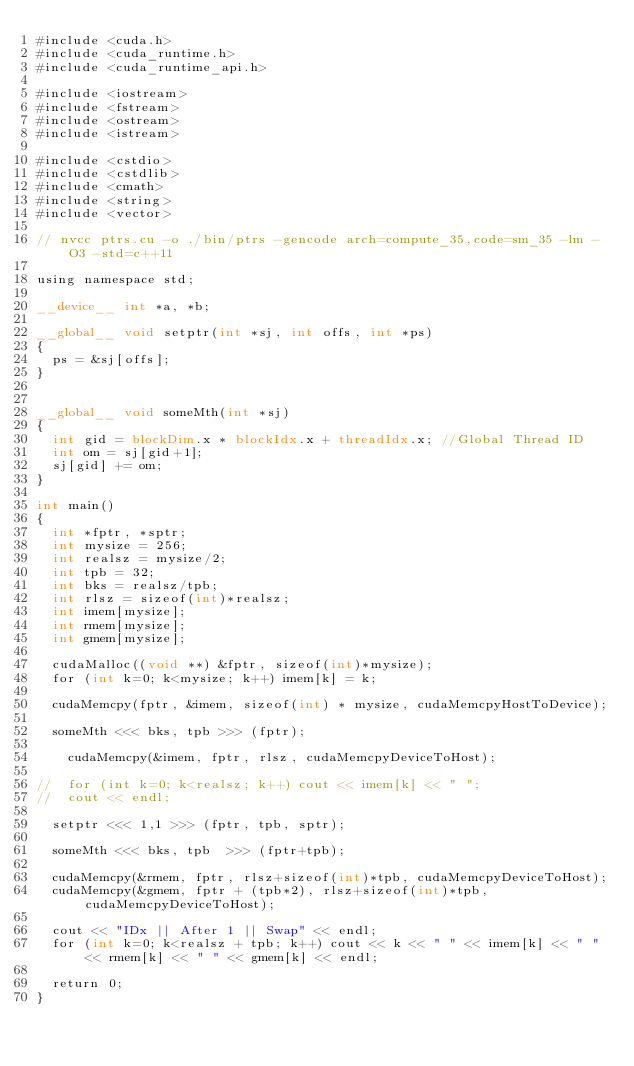Convert code to text. <code><loc_0><loc_0><loc_500><loc_500><_Cuda_>#include <cuda.h>
#include <cuda_runtime.h>
#include <cuda_runtime_api.h>

#include <iostream>
#include <fstream>
#include <ostream>
#include <istream>

#include <cstdio>
#include <cstdlib>
#include <cmath>
#include <string>
#include <vector>

// nvcc ptrs.cu -o ./bin/ptrs -gencode arch=compute_35,code=sm_35 -lm -O3 -std=c++11

using namespace std;

__device__ int *a, *b; 

__global__ void setptr(int *sj, int offs, int *ps)
{
	ps = &sj[offs];
}


__global__ void someMth(int *sj)
{
	int gid = blockDim.x * blockIdx.x + threadIdx.x; //Global Thread ID
	int om = sj[gid+1];
	sj[gid] += om;
}

int main()
{
	int *fptr, *sptr;
	int mysize = 256;
	int realsz = mysize/2;
	int tpb = 32;
	int bks = realsz/tpb;	
	int rlsz = sizeof(int)*realsz;
	int imem[mysize];
	int rmem[mysize]; 
	int gmem[mysize]; 

	cudaMalloc((void **) &fptr, sizeof(int)*mysize);
	for (int k=0; k<mysize; k++) imem[k] = k;

	cudaMemcpy(fptr, &imem, sizeof(int) * mysize, cudaMemcpyHostToDevice);

	someMth <<< bks, tpb >>> (fptr);

    cudaMemcpy(&imem, fptr, rlsz, cudaMemcpyDeviceToHost);

//	for (int k=0; k<realsz; k++) cout << imem[k] << " ";
//	cout << endl;

	setptr <<< 1,1 >>> (fptr, tpb, sptr); 

	someMth <<< bks, tpb  >>> (fptr+tpb);

	cudaMemcpy(&rmem, fptr, rlsz+sizeof(int)*tpb, cudaMemcpyDeviceToHost);
	cudaMemcpy(&gmem, fptr + (tpb*2), rlsz+sizeof(int)*tpb, cudaMemcpyDeviceToHost);

	cout << "IDx || After 1 || Swap" << endl;
	for (int k=0; k<realsz + tpb; k++) cout << k << " " << imem[k] << " " << rmem[k] << " " << gmem[k] << endl;

	return 0;
}
</code> 